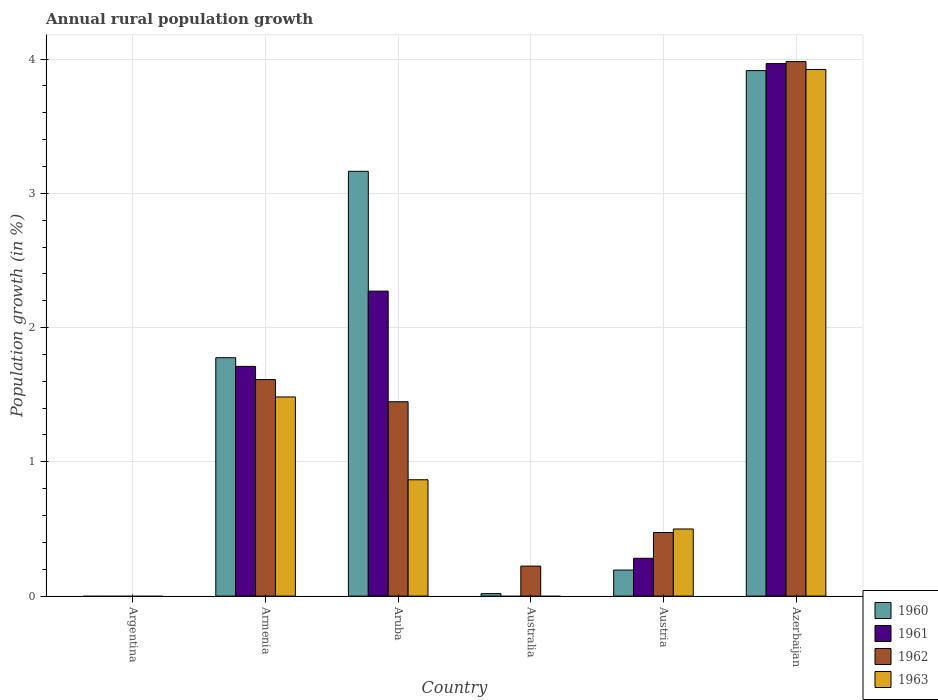How many different coloured bars are there?
Your answer should be compact. 4. Are the number of bars on each tick of the X-axis equal?
Keep it short and to the point. No. How many bars are there on the 6th tick from the right?
Offer a very short reply. 0. What is the label of the 3rd group of bars from the left?
Your answer should be very brief. Aruba. What is the percentage of rural population growth in 1962 in Austria?
Offer a terse response. 0.47. Across all countries, what is the maximum percentage of rural population growth in 1961?
Make the answer very short. 3.97. Across all countries, what is the minimum percentage of rural population growth in 1962?
Provide a succinct answer. 0. In which country was the percentage of rural population growth in 1960 maximum?
Keep it short and to the point. Azerbaijan. What is the total percentage of rural population growth in 1962 in the graph?
Provide a short and direct response. 7.74. What is the difference between the percentage of rural population growth in 1962 in Aruba and that in Australia?
Make the answer very short. 1.22. What is the difference between the percentage of rural population growth in 1960 in Australia and the percentage of rural population growth in 1962 in Azerbaijan?
Your answer should be very brief. -3.96. What is the average percentage of rural population growth in 1960 per country?
Provide a short and direct response. 1.51. What is the difference between the percentage of rural population growth of/in 1962 and percentage of rural population growth of/in 1960 in Azerbaijan?
Your response must be concise. 0.07. In how many countries, is the percentage of rural population growth in 1963 greater than 0.4 %?
Your answer should be compact. 4. What is the ratio of the percentage of rural population growth in 1962 in Australia to that in Austria?
Your response must be concise. 0.47. Is the difference between the percentage of rural population growth in 1962 in Aruba and Austria greater than the difference between the percentage of rural population growth in 1960 in Aruba and Austria?
Provide a succinct answer. No. What is the difference between the highest and the second highest percentage of rural population growth in 1960?
Give a very brief answer. 1.39. What is the difference between the highest and the lowest percentage of rural population growth in 1961?
Your answer should be compact. 3.97. Is it the case that in every country, the sum of the percentage of rural population growth in 1961 and percentage of rural population growth in 1960 is greater than the sum of percentage of rural population growth in 1963 and percentage of rural population growth in 1962?
Your answer should be very brief. No. Is it the case that in every country, the sum of the percentage of rural population growth in 1962 and percentage of rural population growth in 1961 is greater than the percentage of rural population growth in 1960?
Offer a terse response. No. How many countries are there in the graph?
Keep it short and to the point. 6. What is the difference between two consecutive major ticks on the Y-axis?
Your answer should be compact. 1. Does the graph contain grids?
Offer a very short reply. Yes. Where does the legend appear in the graph?
Offer a very short reply. Bottom right. How are the legend labels stacked?
Make the answer very short. Vertical. What is the title of the graph?
Ensure brevity in your answer.  Annual rural population growth. Does "1998" appear as one of the legend labels in the graph?
Offer a very short reply. No. What is the label or title of the X-axis?
Provide a succinct answer. Country. What is the label or title of the Y-axis?
Provide a succinct answer. Population growth (in %). What is the Population growth (in %) in 1961 in Argentina?
Offer a terse response. 0. What is the Population growth (in %) of 1960 in Armenia?
Provide a succinct answer. 1.78. What is the Population growth (in %) in 1961 in Armenia?
Provide a succinct answer. 1.71. What is the Population growth (in %) in 1962 in Armenia?
Your answer should be very brief. 1.61. What is the Population growth (in %) in 1963 in Armenia?
Provide a succinct answer. 1.48. What is the Population growth (in %) in 1960 in Aruba?
Ensure brevity in your answer.  3.16. What is the Population growth (in %) of 1961 in Aruba?
Offer a very short reply. 2.27. What is the Population growth (in %) of 1962 in Aruba?
Your answer should be compact. 1.45. What is the Population growth (in %) in 1963 in Aruba?
Ensure brevity in your answer.  0.87. What is the Population growth (in %) of 1960 in Australia?
Make the answer very short. 0.02. What is the Population growth (in %) of 1961 in Australia?
Keep it short and to the point. 0. What is the Population growth (in %) of 1962 in Australia?
Your answer should be compact. 0.22. What is the Population growth (in %) of 1960 in Austria?
Offer a very short reply. 0.19. What is the Population growth (in %) of 1961 in Austria?
Give a very brief answer. 0.28. What is the Population growth (in %) of 1962 in Austria?
Offer a terse response. 0.47. What is the Population growth (in %) in 1963 in Austria?
Provide a succinct answer. 0.5. What is the Population growth (in %) in 1960 in Azerbaijan?
Keep it short and to the point. 3.91. What is the Population growth (in %) of 1961 in Azerbaijan?
Offer a very short reply. 3.97. What is the Population growth (in %) in 1962 in Azerbaijan?
Offer a very short reply. 3.98. What is the Population growth (in %) in 1963 in Azerbaijan?
Your answer should be compact. 3.92. Across all countries, what is the maximum Population growth (in %) in 1960?
Keep it short and to the point. 3.91. Across all countries, what is the maximum Population growth (in %) of 1961?
Your answer should be compact. 3.97. Across all countries, what is the maximum Population growth (in %) in 1962?
Give a very brief answer. 3.98. Across all countries, what is the maximum Population growth (in %) of 1963?
Ensure brevity in your answer.  3.92. Across all countries, what is the minimum Population growth (in %) in 1960?
Keep it short and to the point. 0. What is the total Population growth (in %) in 1960 in the graph?
Your answer should be very brief. 9.07. What is the total Population growth (in %) in 1961 in the graph?
Your answer should be compact. 8.23. What is the total Population growth (in %) of 1962 in the graph?
Give a very brief answer. 7.74. What is the total Population growth (in %) of 1963 in the graph?
Your response must be concise. 6.77. What is the difference between the Population growth (in %) of 1960 in Armenia and that in Aruba?
Make the answer very short. -1.39. What is the difference between the Population growth (in %) in 1961 in Armenia and that in Aruba?
Your answer should be very brief. -0.56. What is the difference between the Population growth (in %) of 1962 in Armenia and that in Aruba?
Your response must be concise. 0.17. What is the difference between the Population growth (in %) of 1963 in Armenia and that in Aruba?
Give a very brief answer. 0.62. What is the difference between the Population growth (in %) in 1960 in Armenia and that in Australia?
Provide a succinct answer. 1.76. What is the difference between the Population growth (in %) of 1962 in Armenia and that in Australia?
Make the answer very short. 1.39. What is the difference between the Population growth (in %) of 1960 in Armenia and that in Austria?
Offer a very short reply. 1.58. What is the difference between the Population growth (in %) of 1961 in Armenia and that in Austria?
Keep it short and to the point. 1.43. What is the difference between the Population growth (in %) in 1962 in Armenia and that in Austria?
Your answer should be very brief. 1.14. What is the difference between the Population growth (in %) in 1963 in Armenia and that in Austria?
Keep it short and to the point. 0.98. What is the difference between the Population growth (in %) of 1960 in Armenia and that in Azerbaijan?
Make the answer very short. -2.14. What is the difference between the Population growth (in %) of 1961 in Armenia and that in Azerbaijan?
Give a very brief answer. -2.25. What is the difference between the Population growth (in %) in 1962 in Armenia and that in Azerbaijan?
Your answer should be very brief. -2.37. What is the difference between the Population growth (in %) in 1963 in Armenia and that in Azerbaijan?
Offer a terse response. -2.44. What is the difference between the Population growth (in %) in 1960 in Aruba and that in Australia?
Offer a very short reply. 3.15. What is the difference between the Population growth (in %) of 1962 in Aruba and that in Australia?
Your response must be concise. 1.22. What is the difference between the Population growth (in %) in 1960 in Aruba and that in Austria?
Your answer should be very brief. 2.97. What is the difference between the Population growth (in %) in 1961 in Aruba and that in Austria?
Ensure brevity in your answer.  1.99. What is the difference between the Population growth (in %) in 1962 in Aruba and that in Austria?
Offer a terse response. 0.97. What is the difference between the Population growth (in %) of 1963 in Aruba and that in Austria?
Your answer should be very brief. 0.37. What is the difference between the Population growth (in %) of 1960 in Aruba and that in Azerbaijan?
Offer a very short reply. -0.75. What is the difference between the Population growth (in %) of 1961 in Aruba and that in Azerbaijan?
Give a very brief answer. -1.69. What is the difference between the Population growth (in %) of 1962 in Aruba and that in Azerbaijan?
Provide a short and direct response. -2.53. What is the difference between the Population growth (in %) of 1963 in Aruba and that in Azerbaijan?
Ensure brevity in your answer.  -3.06. What is the difference between the Population growth (in %) of 1960 in Australia and that in Austria?
Keep it short and to the point. -0.18. What is the difference between the Population growth (in %) of 1962 in Australia and that in Austria?
Your response must be concise. -0.25. What is the difference between the Population growth (in %) in 1960 in Australia and that in Azerbaijan?
Your answer should be very brief. -3.9. What is the difference between the Population growth (in %) of 1962 in Australia and that in Azerbaijan?
Ensure brevity in your answer.  -3.76. What is the difference between the Population growth (in %) in 1960 in Austria and that in Azerbaijan?
Make the answer very short. -3.72. What is the difference between the Population growth (in %) in 1961 in Austria and that in Azerbaijan?
Keep it short and to the point. -3.68. What is the difference between the Population growth (in %) in 1962 in Austria and that in Azerbaijan?
Give a very brief answer. -3.51. What is the difference between the Population growth (in %) in 1963 in Austria and that in Azerbaijan?
Offer a very short reply. -3.42. What is the difference between the Population growth (in %) in 1960 in Armenia and the Population growth (in %) in 1961 in Aruba?
Your answer should be compact. -0.5. What is the difference between the Population growth (in %) in 1960 in Armenia and the Population growth (in %) in 1962 in Aruba?
Provide a succinct answer. 0.33. What is the difference between the Population growth (in %) in 1960 in Armenia and the Population growth (in %) in 1963 in Aruba?
Offer a terse response. 0.91. What is the difference between the Population growth (in %) in 1961 in Armenia and the Population growth (in %) in 1962 in Aruba?
Your answer should be compact. 0.26. What is the difference between the Population growth (in %) in 1961 in Armenia and the Population growth (in %) in 1963 in Aruba?
Your answer should be compact. 0.84. What is the difference between the Population growth (in %) in 1962 in Armenia and the Population growth (in %) in 1963 in Aruba?
Keep it short and to the point. 0.75. What is the difference between the Population growth (in %) of 1960 in Armenia and the Population growth (in %) of 1962 in Australia?
Provide a short and direct response. 1.55. What is the difference between the Population growth (in %) of 1961 in Armenia and the Population growth (in %) of 1962 in Australia?
Make the answer very short. 1.49. What is the difference between the Population growth (in %) in 1960 in Armenia and the Population growth (in %) in 1961 in Austria?
Offer a terse response. 1.49. What is the difference between the Population growth (in %) of 1960 in Armenia and the Population growth (in %) of 1962 in Austria?
Offer a terse response. 1.3. What is the difference between the Population growth (in %) in 1960 in Armenia and the Population growth (in %) in 1963 in Austria?
Give a very brief answer. 1.28. What is the difference between the Population growth (in %) of 1961 in Armenia and the Population growth (in %) of 1962 in Austria?
Give a very brief answer. 1.24. What is the difference between the Population growth (in %) of 1961 in Armenia and the Population growth (in %) of 1963 in Austria?
Your answer should be very brief. 1.21. What is the difference between the Population growth (in %) of 1962 in Armenia and the Population growth (in %) of 1963 in Austria?
Offer a very short reply. 1.11. What is the difference between the Population growth (in %) in 1960 in Armenia and the Population growth (in %) in 1961 in Azerbaijan?
Offer a terse response. -2.19. What is the difference between the Population growth (in %) of 1960 in Armenia and the Population growth (in %) of 1962 in Azerbaijan?
Offer a very short reply. -2.21. What is the difference between the Population growth (in %) of 1960 in Armenia and the Population growth (in %) of 1963 in Azerbaijan?
Make the answer very short. -2.15. What is the difference between the Population growth (in %) of 1961 in Armenia and the Population growth (in %) of 1962 in Azerbaijan?
Your answer should be very brief. -2.27. What is the difference between the Population growth (in %) in 1961 in Armenia and the Population growth (in %) in 1963 in Azerbaijan?
Your response must be concise. -2.21. What is the difference between the Population growth (in %) of 1962 in Armenia and the Population growth (in %) of 1963 in Azerbaijan?
Provide a succinct answer. -2.31. What is the difference between the Population growth (in %) in 1960 in Aruba and the Population growth (in %) in 1962 in Australia?
Ensure brevity in your answer.  2.94. What is the difference between the Population growth (in %) of 1961 in Aruba and the Population growth (in %) of 1962 in Australia?
Your answer should be compact. 2.05. What is the difference between the Population growth (in %) in 1960 in Aruba and the Population growth (in %) in 1961 in Austria?
Offer a very short reply. 2.88. What is the difference between the Population growth (in %) of 1960 in Aruba and the Population growth (in %) of 1962 in Austria?
Make the answer very short. 2.69. What is the difference between the Population growth (in %) of 1960 in Aruba and the Population growth (in %) of 1963 in Austria?
Offer a terse response. 2.66. What is the difference between the Population growth (in %) in 1961 in Aruba and the Population growth (in %) in 1962 in Austria?
Your response must be concise. 1.8. What is the difference between the Population growth (in %) in 1961 in Aruba and the Population growth (in %) in 1963 in Austria?
Your answer should be very brief. 1.77. What is the difference between the Population growth (in %) in 1962 in Aruba and the Population growth (in %) in 1963 in Austria?
Provide a short and direct response. 0.95. What is the difference between the Population growth (in %) in 1960 in Aruba and the Population growth (in %) in 1961 in Azerbaijan?
Keep it short and to the point. -0.8. What is the difference between the Population growth (in %) of 1960 in Aruba and the Population growth (in %) of 1962 in Azerbaijan?
Keep it short and to the point. -0.82. What is the difference between the Population growth (in %) in 1960 in Aruba and the Population growth (in %) in 1963 in Azerbaijan?
Give a very brief answer. -0.76. What is the difference between the Population growth (in %) in 1961 in Aruba and the Population growth (in %) in 1962 in Azerbaijan?
Provide a succinct answer. -1.71. What is the difference between the Population growth (in %) in 1961 in Aruba and the Population growth (in %) in 1963 in Azerbaijan?
Your answer should be very brief. -1.65. What is the difference between the Population growth (in %) of 1962 in Aruba and the Population growth (in %) of 1963 in Azerbaijan?
Provide a short and direct response. -2.47. What is the difference between the Population growth (in %) in 1960 in Australia and the Population growth (in %) in 1961 in Austria?
Make the answer very short. -0.26. What is the difference between the Population growth (in %) of 1960 in Australia and the Population growth (in %) of 1962 in Austria?
Your answer should be compact. -0.46. What is the difference between the Population growth (in %) of 1960 in Australia and the Population growth (in %) of 1963 in Austria?
Ensure brevity in your answer.  -0.48. What is the difference between the Population growth (in %) in 1962 in Australia and the Population growth (in %) in 1963 in Austria?
Offer a very short reply. -0.28. What is the difference between the Population growth (in %) in 1960 in Australia and the Population growth (in %) in 1961 in Azerbaijan?
Provide a succinct answer. -3.95. What is the difference between the Population growth (in %) in 1960 in Australia and the Population growth (in %) in 1962 in Azerbaijan?
Give a very brief answer. -3.96. What is the difference between the Population growth (in %) of 1960 in Australia and the Population growth (in %) of 1963 in Azerbaijan?
Offer a terse response. -3.9. What is the difference between the Population growth (in %) of 1962 in Australia and the Population growth (in %) of 1963 in Azerbaijan?
Ensure brevity in your answer.  -3.7. What is the difference between the Population growth (in %) in 1960 in Austria and the Population growth (in %) in 1961 in Azerbaijan?
Provide a succinct answer. -3.77. What is the difference between the Population growth (in %) of 1960 in Austria and the Population growth (in %) of 1962 in Azerbaijan?
Offer a terse response. -3.79. What is the difference between the Population growth (in %) of 1960 in Austria and the Population growth (in %) of 1963 in Azerbaijan?
Provide a short and direct response. -3.73. What is the difference between the Population growth (in %) of 1961 in Austria and the Population growth (in %) of 1962 in Azerbaijan?
Provide a succinct answer. -3.7. What is the difference between the Population growth (in %) of 1961 in Austria and the Population growth (in %) of 1963 in Azerbaijan?
Your answer should be compact. -3.64. What is the difference between the Population growth (in %) of 1962 in Austria and the Population growth (in %) of 1963 in Azerbaijan?
Provide a succinct answer. -3.45. What is the average Population growth (in %) of 1960 per country?
Make the answer very short. 1.51. What is the average Population growth (in %) in 1961 per country?
Make the answer very short. 1.37. What is the average Population growth (in %) of 1962 per country?
Your answer should be very brief. 1.29. What is the average Population growth (in %) of 1963 per country?
Make the answer very short. 1.13. What is the difference between the Population growth (in %) in 1960 and Population growth (in %) in 1961 in Armenia?
Give a very brief answer. 0.06. What is the difference between the Population growth (in %) in 1960 and Population growth (in %) in 1962 in Armenia?
Your answer should be compact. 0.16. What is the difference between the Population growth (in %) in 1960 and Population growth (in %) in 1963 in Armenia?
Keep it short and to the point. 0.29. What is the difference between the Population growth (in %) in 1961 and Population growth (in %) in 1962 in Armenia?
Make the answer very short. 0.1. What is the difference between the Population growth (in %) of 1961 and Population growth (in %) of 1963 in Armenia?
Offer a very short reply. 0.23. What is the difference between the Population growth (in %) of 1962 and Population growth (in %) of 1963 in Armenia?
Ensure brevity in your answer.  0.13. What is the difference between the Population growth (in %) in 1960 and Population growth (in %) in 1961 in Aruba?
Keep it short and to the point. 0.89. What is the difference between the Population growth (in %) of 1960 and Population growth (in %) of 1962 in Aruba?
Ensure brevity in your answer.  1.72. What is the difference between the Population growth (in %) in 1960 and Population growth (in %) in 1963 in Aruba?
Provide a short and direct response. 2.3. What is the difference between the Population growth (in %) in 1961 and Population growth (in %) in 1962 in Aruba?
Give a very brief answer. 0.82. What is the difference between the Population growth (in %) of 1961 and Population growth (in %) of 1963 in Aruba?
Offer a terse response. 1.4. What is the difference between the Population growth (in %) in 1962 and Population growth (in %) in 1963 in Aruba?
Your response must be concise. 0.58. What is the difference between the Population growth (in %) in 1960 and Population growth (in %) in 1962 in Australia?
Offer a terse response. -0.2. What is the difference between the Population growth (in %) in 1960 and Population growth (in %) in 1961 in Austria?
Offer a terse response. -0.09. What is the difference between the Population growth (in %) in 1960 and Population growth (in %) in 1962 in Austria?
Ensure brevity in your answer.  -0.28. What is the difference between the Population growth (in %) in 1960 and Population growth (in %) in 1963 in Austria?
Make the answer very short. -0.31. What is the difference between the Population growth (in %) of 1961 and Population growth (in %) of 1962 in Austria?
Your response must be concise. -0.19. What is the difference between the Population growth (in %) of 1961 and Population growth (in %) of 1963 in Austria?
Ensure brevity in your answer.  -0.22. What is the difference between the Population growth (in %) in 1962 and Population growth (in %) in 1963 in Austria?
Ensure brevity in your answer.  -0.03. What is the difference between the Population growth (in %) in 1960 and Population growth (in %) in 1961 in Azerbaijan?
Provide a short and direct response. -0.05. What is the difference between the Population growth (in %) in 1960 and Population growth (in %) in 1962 in Azerbaijan?
Provide a succinct answer. -0.07. What is the difference between the Population growth (in %) in 1960 and Population growth (in %) in 1963 in Azerbaijan?
Provide a short and direct response. -0.01. What is the difference between the Population growth (in %) in 1961 and Population growth (in %) in 1962 in Azerbaijan?
Give a very brief answer. -0.01. What is the difference between the Population growth (in %) in 1961 and Population growth (in %) in 1963 in Azerbaijan?
Offer a terse response. 0.04. What is the difference between the Population growth (in %) of 1962 and Population growth (in %) of 1963 in Azerbaijan?
Keep it short and to the point. 0.06. What is the ratio of the Population growth (in %) in 1960 in Armenia to that in Aruba?
Provide a succinct answer. 0.56. What is the ratio of the Population growth (in %) of 1961 in Armenia to that in Aruba?
Offer a terse response. 0.75. What is the ratio of the Population growth (in %) of 1962 in Armenia to that in Aruba?
Provide a succinct answer. 1.11. What is the ratio of the Population growth (in %) of 1963 in Armenia to that in Aruba?
Offer a very short reply. 1.71. What is the ratio of the Population growth (in %) of 1960 in Armenia to that in Australia?
Offer a terse response. 95.73. What is the ratio of the Population growth (in %) in 1962 in Armenia to that in Australia?
Your answer should be compact. 7.22. What is the ratio of the Population growth (in %) in 1960 in Armenia to that in Austria?
Keep it short and to the point. 9.16. What is the ratio of the Population growth (in %) of 1961 in Armenia to that in Austria?
Ensure brevity in your answer.  6.07. What is the ratio of the Population growth (in %) in 1962 in Armenia to that in Austria?
Your response must be concise. 3.41. What is the ratio of the Population growth (in %) of 1963 in Armenia to that in Austria?
Your answer should be very brief. 2.97. What is the ratio of the Population growth (in %) of 1960 in Armenia to that in Azerbaijan?
Keep it short and to the point. 0.45. What is the ratio of the Population growth (in %) of 1961 in Armenia to that in Azerbaijan?
Give a very brief answer. 0.43. What is the ratio of the Population growth (in %) of 1962 in Armenia to that in Azerbaijan?
Keep it short and to the point. 0.41. What is the ratio of the Population growth (in %) in 1963 in Armenia to that in Azerbaijan?
Your response must be concise. 0.38. What is the ratio of the Population growth (in %) of 1960 in Aruba to that in Australia?
Your answer should be very brief. 170.6. What is the ratio of the Population growth (in %) in 1962 in Aruba to that in Australia?
Offer a very short reply. 6.48. What is the ratio of the Population growth (in %) in 1960 in Aruba to that in Austria?
Keep it short and to the point. 16.32. What is the ratio of the Population growth (in %) in 1961 in Aruba to that in Austria?
Offer a terse response. 8.06. What is the ratio of the Population growth (in %) of 1962 in Aruba to that in Austria?
Ensure brevity in your answer.  3.06. What is the ratio of the Population growth (in %) of 1963 in Aruba to that in Austria?
Offer a very short reply. 1.73. What is the ratio of the Population growth (in %) in 1960 in Aruba to that in Azerbaijan?
Make the answer very short. 0.81. What is the ratio of the Population growth (in %) of 1961 in Aruba to that in Azerbaijan?
Make the answer very short. 0.57. What is the ratio of the Population growth (in %) in 1962 in Aruba to that in Azerbaijan?
Provide a succinct answer. 0.36. What is the ratio of the Population growth (in %) in 1963 in Aruba to that in Azerbaijan?
Provide a short and direct response. 0.22. What is the ratio of the Population growth (in %) in 1960 in Australia to that in Austria?
Your answer should be very brief. 0.1. What is the ratio of the Population growth (in %) of 1962 in Australia to that in Austria?
Provide a succinct answer. 0.47. What is the ratio of the Population growth (in %) of 1960 in Australia to that in Azerbaijan?
Keep it short and to the point. 0. What is the ratio of the Population growth (in %) of 1962 in Australia to that in Azerbaijan?
Give a very brief answer. 0.06. What is the ratio of the Population growth (in %) in 1960 in Austria to that in Azerbaijan?
Your answer should be compact. 0.05. What is the ratio of the Population growth (in %) in 1961 in Austria to that in Azerbaijan?
Give a very brief answer. 0.07. What is the ratio of the Population growth (in %) of 1962 in Austria to that in Azerbaijan?
Provide a short and direct response. 0.12. What is the ratio of the Population growth (in %) in 1963 in Austria to that in Azerbaijan?
Your response must be concise. 0.13. What is the difference between the highest and the second highest Population growth (in %) in 1960?
Your answer should be compact. 0.75. What is the difference between the highest and the second highest Population growth (in %) in 1961?
Keep it short and to the point. 1.69. What is the difference between the highest and the second highest Population growth (in %) of 1962?
Provide a short and direct response. 2.37. What is the difference between the highest and the second highest Population growth (in %) in 1963?
Your answer should be compact. 2.44. What is the difference between the highest and the lowest Population growth (in %) of 1960?
Offer a terse response. 3.91. What is the difference between the highest and the lowest Population growth (in %) of 1961?
Give a very brief answer. 3.97. What is the difference between the highest and the lowest Population growth (in %) of 1962?
Provide a short and direct response. 3.98. What is the difference between the highest and the lowest Population growth (in %) in 1963?
Your response must be concise. 3.92. 